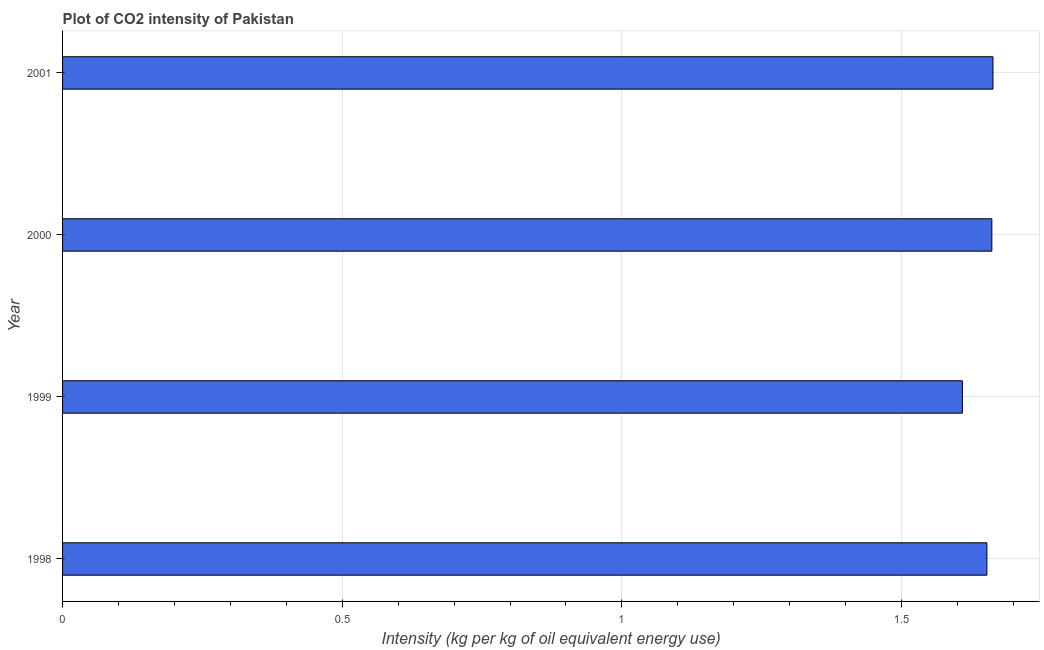Does the graph contain any zero values?
Your response must be concise. No. Does the graph contain grids?
Your answer should be compact. Yes. What is the title of the graph?
Provide a succinct answer. Plot of CO2 intensity of Pakistan. What is the label or title of the X-axis?
Offer a very short reply. Intensity (kg per kg of oil equivalent energy use). What is the co2 intensity in 2001?
Your answer should be compact. 1.66. Across all years, what is the maximum co2 intensity?
Provide a short and direct response. 1.66. Across all years, what is the minimum co2 intensity?
Keep it short and to the point. 1.61. What is the sum of the co2 intensity?
Your answer should be compact. 6.59. What is the difference between the co2 intensity in 1999 and 2000?
Ensure brevity in your answer.  -0.05. What is the average co2 intensity per year?
Your answer should be compact. 1.65. What is the median co2 intensity?
Provide a short and direct response. 1.66. What is the ratio of the co2 intensity in 1999 to that in 2000?
Your response must be concise. 0.97. Is the co2 intensity in 1998 less than that in 1999?
Provide a short and direct response. No. Is the difference between the co2 intensity in 1998 and 1999 greater than the difference between any two years?
Offer a terse response. No. What is the difference between the highest and the second highest co2 intensity?
Keep it short and to the point. 0. Is the sum of the co2 intensity in 1998 and 1999 greater than the maximum co2 intensity across all years?
Your answer should be very brief. Yes. How many bars are there?
Offer a very short reply. 4. What is the Intensity (kg per kg of oil equivalent energy use) in 1998?
Offer a very short reply. 1.65. What is the Intensity (kg per kg of oil equivalent energy use) in 1999?
Offer a terse response. 1.61. What is the Intensity (kg per kg of oil equivalent energy use) in 2000?
Provide a short and direct response. 1.66. What is the Intensity (kg per kg of oil equivalent energy use) in 2001?
Provide a short and direct response. 1.66. What is the difference between the Intensity (kg per kg of oil equivalent energy use) in 1998 and 1999?
Keep it short and to the point. 0.04. What is the difference between the Intensity (kg per kg of oil equivalent energy use) in 1998 and 2000?
Make the answer very short. -0.01. What is the difference between the Intensity (kg per kg of oil equivalent energy use) in 1998 and 2001?
Make the answer very short. -0.01. What is the difference between the Intensity (kg per kg of oil equivalent energy use) in 1999 and 2000?
Offer a terse response. -0.05. What is the difference between the Intensity (kg per kg of oil equivalent energy use) in 1999 and 2001?
Offer a very short reply. -0.05. What is the difference between the Intensity (kg per kg of oil equivalent energy use) in 2000 and 2001?
Provide a succinct answer. -0. What is the ratio of the Intensity (kg per kg of oil equivalent energy use) in 1998 to that in 1999?
Keep it short and to the point. 1.03. What is the ratio of the Intensity (kg per kg of oil equivalent energy use) in 1998 to that in 2001?
Give a very brief answer. 0.99. What is the ratio of the Intensity (kg per kg of oil equivalent energy use) in 1999 to that in 2000?
Provide a succinct answer. 0.97. What is the ratio of the Intensity (kg per kg of oil equivalent energy use) in 1999 to that in 2001?
Your answer should be very brief. 0.97. 